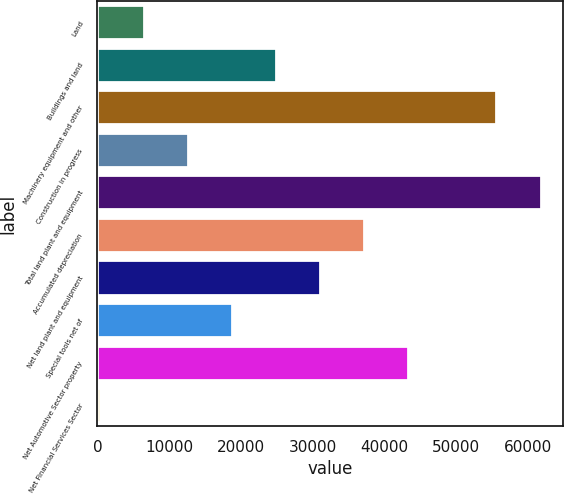Convert chart. <chart><loc_0><loc_0><loc_500><loc_500><bar_chart><fcel>Land<fcel>Buildings and land<fcel>Machinery equipment and other<fcel>Construction in progress<fcel>Total land plant and equipment<fcel>Accumulated depreciation<fcel>Net land plant and equipment<fcel>Special tools net of<fcel>Net Automotive Sector property<fcel>Net Financial Services Sector<nl><fcel>6547.8<fcel>24964.2<fcel>55658.2<fcel>12686.6<fcel>61797<fcel>37241.8<fcel>31103<fcel>18825.4<fcel>43380.6<fcel>409<nl></chart> 